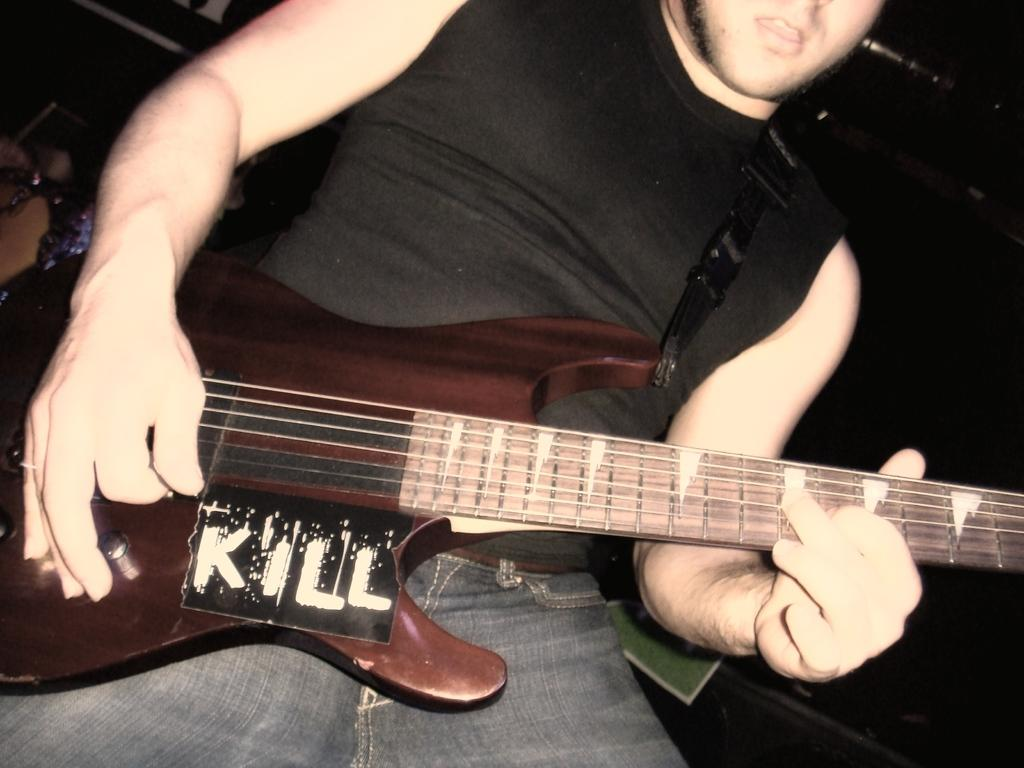What is the main subject of the image? There is a person in the image. What is the person doing in the image? The person is playing a guitar. What is the person wearing in the image? The person is wearing a black t-shirt. How much dirt is present in the image? There is no dirt present in the image; it is not mentioned in the provided facts. 